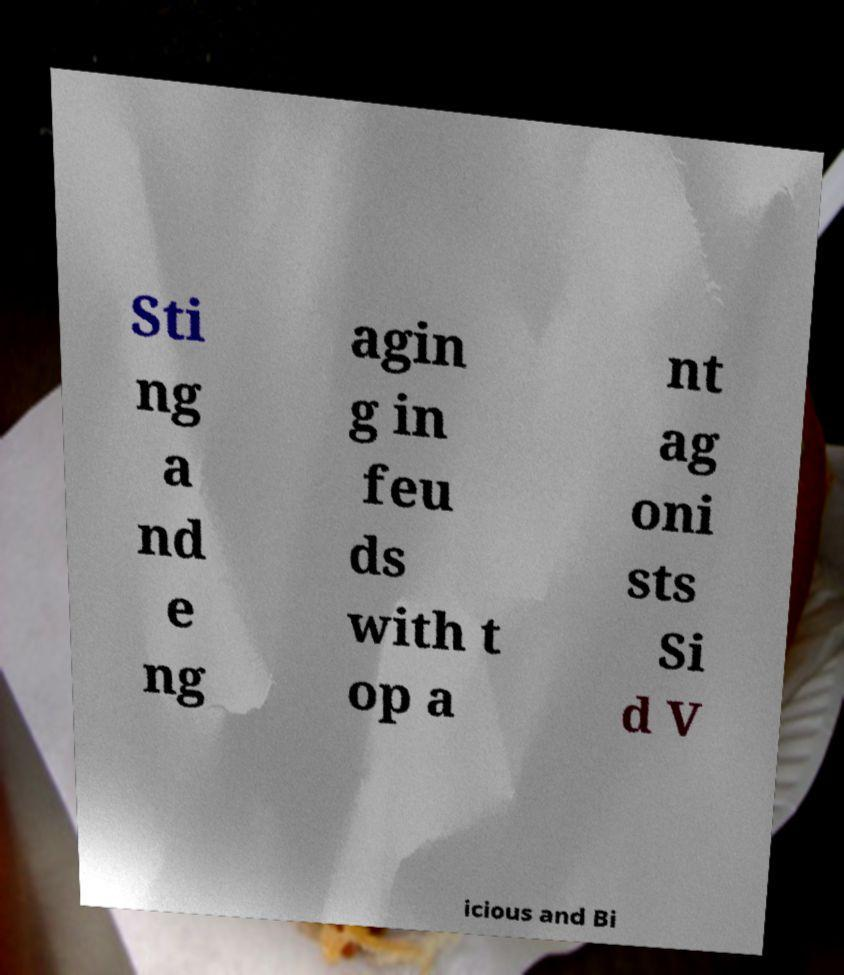Can you accurately transcribe the text from the provided image for me? Sti ng a nd e ng agin g in feu ds with t op a nt ag oni sts Si d V icious and Bi 